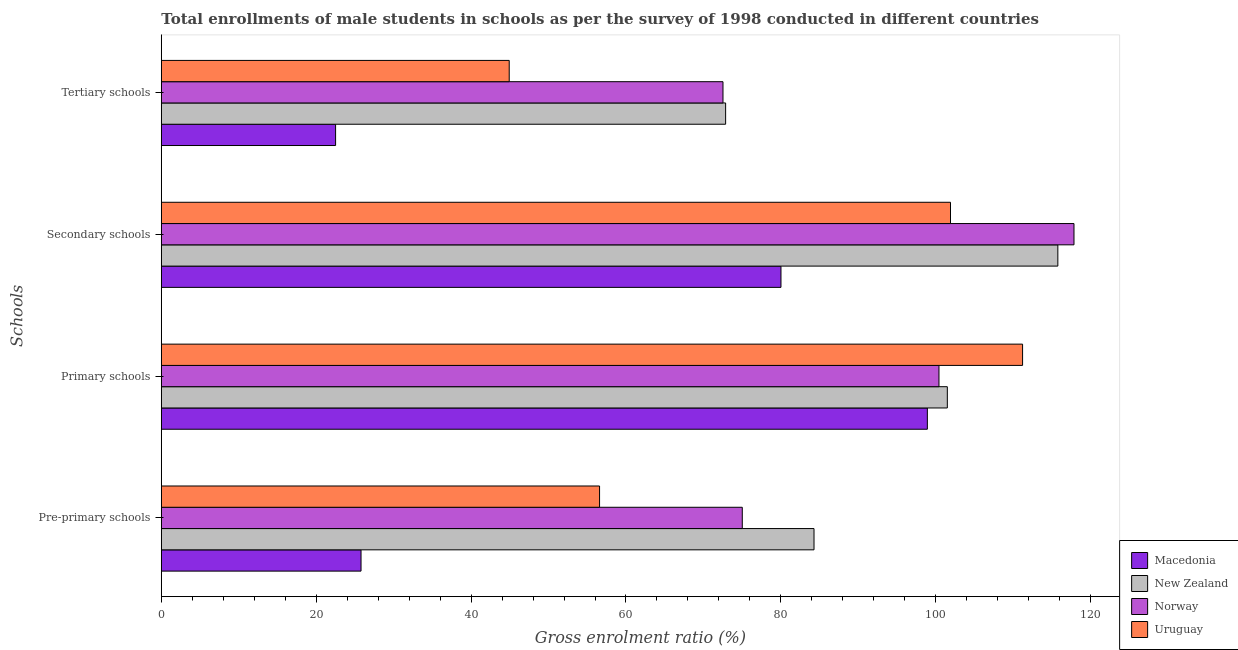How many groups of bars are there?
Make the answer very short. 4. How many bars are there on the 1st tick from the top?
Offer a terse response. 4. What is the label of the 4th group of bars from the top?
Your answer should be very brief. Pre-primary schools. What is the gross enrolment ratio(male) in pre-primary schools in Uruguay?
Your response must be concise. 56.59. Across all countries, what is the maximum gross enrolment ratio(male) in secondary schools?
Provide a succinct answer. 117.85. Across all countries, what is the minimum gross enrolment ratio(male) in primary schools?
Your answer should be compact. 98.91. In which country was the gross enrolment ratio(male) in tertiary schools maximum?
Your response must be concise. New Zealand. In which country was the gross enrolment ratio(male) in primary schools minimum?
Offer a very short reply. Macedonia. What is the total gross enrolment ratio(male) in tertiary schools in the graph?
Offer a terse response. 212.81. What is the difference between the gross enrolment ratio(male) in pre-primary schools in Macedonia and that in New Zealand?
Your response must be concise. -58.49. What is the difference between the gross enrolment ratio(male) in primary schools in Uruguay and the gross enrolment ratio(male) in secondary schools in Macedonia?
Your answer should be very brief. 31.2. What is the average gross enrolment ratio(male) in tertiary schools per country?
Give a very brief answer. 53.2. What is the difference between the gross enrolment ratio(male) in pre-primary schools and gross enrolment ratio(male) in primary schools in Norway?
Offer a very short reply. -25.4. In how many countries, is the gross enrolment ratio(male) in primary schools greater than 8 %?
Ensure brevity in your answer.  4. What is the ratio of the gross enrolment ratio(male) in pre-primary schools in Uruguay to that in New Zealand?
Provide a succinct answer. 0.67. Is the difference between the gross enrolment ratio(male) in tertiary schools in Uruguay and New Zealand greater than the difference between the gross enrolment ratio(male) in pre-primary schools in Uruguay and New Zealand?
Your response must be concise. No. What is the difference between the highest and the second highest gross enrolment ratio(male) in tertiary schools?
Your answer should be compact. 0.34. What is the difference between the highest and the lowest gross enrolment ratio(male) in tertiary schools?
Offer a very short reply. 50.36. In how many countries, is the gross enrolment ratio(male) in primary schools greater than the average gross enrolment ratio(male) in primary schools taken over all countries?
Your response must be concise. 1. Is the sum of the gross enrolment ratio(male) in secondary schools in New Zealand and Uruguay greater than the maximum gross enrolment ratio(male) in primary schools across all countries?
Give a very brief answer. Yes. What does the 2nd bar from the top in Tertiary schools represents?
Offer a very short reply. Norway. What does the 4th bar from the bottom in Secondary schools represents?
Your response must be concise. Uruguay. Is it the case that in every country, the sum of the gross enrolment ratio(male) in pre-primary schools and gross enrolment ratio(male) in primary schools is greater than the gross enrolment ratio(male) in secondary schools?
Ensure brevity in your answer.  Yes. How many bars are there?
Offer a very short reply. 16. Are all the bars in the graph horizontal?
Make the answer very short. Yes. How many countries are there in the graph?
Your answer should be compact. 4. Does the graph contain any zero values?
Give a very brief answer. No. How many legend labels are there?
Provide a succinct answer. 4. What is the title of the graph?
Make the answer very short. Total enrollments of male students in schools as per the survey of 1998 conducted in different countries. What is the label or title of the Y-axis?
Provide a succinct answer. Schools. What is the Gross enrolment ratio (%) of Macedonia in Pre-primary schools?
Ensure brevity in your answer.  25.79. What is the Gross enrolment ratio (%) of New Zealand in Pre-primary schools?
Your answer should be compact. 84.28. What is the Gross enrolment ratio (%) of Norway in Pre-primary schools?
Your response must be concise. 75.02. What is the Gross enrolment ratio (%) of Uruguay in Pre-primary schools?
Keep it short and to the point. 56.59. What is the Gross enrolment ratio (%) in Macedonia in Primary schools?
Your response must be concise. 98.91. What is the Gross enrolment ratio (%) of New Zealand in Primary schools?
Offer a terse response. 101.49. What is the Gross enrolment ratio (%) in Norway in Primary schools?
Keep it short and to the point. 100.41. What is the Gross enrolment ratio (%) of Uruguay in Primary schools?
Keep it short and to the point. 111.21. What is the Gross enrolment ratio (%) of Macedonia in Secondary schools?
Offer a very short reply. 80.01. What is the Gross enrolment ratio (%) in New Zealand in Secondary schools?
Give a very brief answer. 115.76. What is the Gross enrolment ratio (%) of Norway in Secondary schools?
Offer a very short reply. 117.85. What is the Gross enrolment ratio (%) of Uruguay in Secondary schools?
Ensure brevity in your answer.  101.9. What is the Gross enrolment ratio (%) in Macedonia in Tertiary schools?
Ensure brevity in your answer.  22.5. What is the Gross enrolment ratio (%) in New Zealand in Tertiary schools?
Your answer should be compact. 72.86. What is the Gross enrolment ratio (%) in Norway in Tertiary schools?
Make the answer very short. 72.52. What is the Gross enrolment ratio (%) of Uruguay in Tertiary schools?
Your response must be concise. 44.92. Across all Schools, what is the maximum Gross enrolment ratio (%) in Macedonia?
Your response must be concise. 98.91. Across all Schools, what is the maximum Gross enrolment ratio (%) of New Zealand?
Ensure brevity in your answer.  115.76. Across all Schools, what is the maximum Gross enrolment ratio (%) of Norway?
Give a very brief answer. 117.85. Across all Schools, what is the maximum Gross enrolment ratio (%) of Uruguay?
Your answer should be very brief. 111.21. Across all Schools, what is the minimum Gross enrolment ratio (%) in Macedonia?
Make the answer very short. 22.5. Across all Schools, what is the minimum Gross enrolment ratio (%) in New Zealand?
Your answer should be very brief. 72.86. Across all Schools, what is the minimum Gross enrolment ratio (%) of Norway?
Offer a very short reply. 72.52. Across all Schools, what is the minimum Gross enrolment ratio (%) in Uruguay?
Ensure brevity in your answer.  44.92. What is the total Gross enrolment ratio (%) in Macedonia in the graph?
Offer a very short reply. 227.22. What is the total Gross enrolment ratio (%) of New Zealand in the graph?
Your answer should be very brief. 374.4. What is the total Gross enrolment ratio (%) in Norway in the graph?
Ensure brevity in your answer.  365.8. What is the total Gross enrolment ratio (%) of Uruguay in the graph?
Give a very brief answer. 314.62. What is the difference between the Gross enrolment ratio (%) in Macedonia in Pre-primary schools and that in Primary schools?
Provide a succinct answer. -73.13. What is the difference between the Gross enrolment ratio (%) of New Zealand in Pre-primary schools and that in Primary schools?
Make the answer very short. -17.21. What is the difference between the Gross enrolment ratio (%) of Norway in Pre-primary schools and that in Primary schools?
Your answer should be very brief. -25.4. What is the difference between the Gross enrolment ratio (%) in Uruguay in Pre-primary schools and that in Primary schools?
Your answer should be very brief. -54.62. What is the difference between the Gross enrolment ratio (%) of Macedonia in Pre-primary schools and that in Secondary schools?
Provide a succinct answer. -54.23. What is the difference between the Gross enrolment ratio (%) in New Zealand in Pre-primary schools and that in Secondary schools?
Make the answer very short. -31.49. What is the difference between the Gross enrolment ratio (%) in Norway in Pre-primary schools and that in Secondary schools?
Provide a short and direct response. -42.83. What is the difference between the Gross enrolment ratio (%) in Uruguay in Pre-primary schools and that in Secondary schools?
Your answer should be compact. -45.32. What is the difference between the Gross enrolment ratio (%) in Macedonia in Pre-primary schools and that in Tertiary schools?
Offer a terse response. 3.28. What is the difference between the Gross enrolment ratio (%) of New Zealand in Pre-primary schools and that in Tertiary schools?
Ensure brevity in your answer.  11.41. What is the difference between the Gross enrolment ratio (%) of Norway in Pre-primary schools and that in Tertiary schools?
Ensure brevity in your answer.  2.49. What is the difference between the Gross enrolment ratio (%) of Uruguay in Pre-primary schools and that in Tertiary schools?
Offer a very short reply. 11.67. What is the difference between the Gross enrolment ratio (%) of Macedonia in Primary schools and that in Secondary schools?
Ensure brevity in your answer.  18.9. What is the difference between the Gross enrolment ratio (%) in New Zealand in Primary schools and that in Secondary schools?
Your answer should be compact. -14.27. What is the difference between the Gross enrolment ratio (%) in Norway in Primary schools and that in Secondary schools?
Keep it short and to the point. -17.43. What is the difference between the Gross enrolment ratio (%) of Uruguay in Primary schools and that in Secondary schools?
Your answer should be very brief. 9.31. What is the difference between the Gross enrolment ratio (%) of Macedonia in Primary schools and that in Tertiary schools?
Ensure brevity in your answer.  76.41. What is the difference between the Gross enrolment ratio (%) of New Zealand in Primary schools and that in Tertiary schools?
Offer a very short reply. 28.63. What is the difference between the Gross enrolment ratio (%) in Norway in Primary schools and that in Tertiary schools?
Your answer should be very brief. 27.89. What is the difference between the Gross enrolment ratio (%) of Uruguay in Primary schools and that in Tertiary schools?
Provide a succinct answer. 66.29. What is the difference between the Gross enrolment ratio (%) in Macedonia in Secondary schools and that in Tertiary schools?
Ensure brevity in your answer.  57.51. What is the difference between the Gross enrolment ratio (%) in New Zealand in Secondary schools and that in Tertiary schools?
Provide a short and direct response. 42.9. What is the difference between the Gross enrolment ratio (%) of Norway in Secondary schools and that in Tertiary schools?
Ensure brevity in your answer.  45.32. What is the difference between the Gross enrolment ratio (%) in Uruguay in Secondary schools and that in Tertiary schools?
Your answer should be compact. 56.98. What is the difference between the Gross enrolment ratio (%) of Macedonia in Pre-primary schools and the Gross enrolment ratio (%) of New Zealand in Primary schools?
Offer a terse response. -75.71. What is the difference between the Gross enrolment ratio (%) in Macedonia in Pre-primary schools and the Gross enrolment ratio (%) in Norway in Primary schools?
Your answer should be very brief. -74.63. What is the difference between the Gross enrolment ratio (%) in Macedonia in Pre-primary schools and the Gross enrolment ratio (%) in Uruguay in Primary schools?
Keep it short and to the point. -85.42. What is the difference between the Gross enrolment ratio (%) in New Zealand in Pre-primary schools and the Gross enrolment ratio (%) in Norway in Primary schools?
Offer a very short reply. -16.13. What is the difference between the Gross enrolment ratio (%) in New Zealand in Pre-primary schools and the Gross enrolment ratio (%) in Uruguay in Primary schools?
Give a very brief answer. -26.93. What is the difference between the Gross enrolment ratio (%) in Norway in Pre-primary schools and the Gross enrolment ratio (%) in Uruguay in Primary schools?
Your answer should be very brief. -36.19. What is the difference between the Gross enrolment ratio (%) of Macedonia in Pre-primary schools and the Gross enrolment ratio (%) of New Zealand in Secondary schools?
Ensure brevity in your answer.  -89.98. What is the difference between the Gross enrolment ratio (%) in Macedonia in Pre-primary schools and the Gross enrolment ratio (%) in Norway in Secondary schools?
Keep it short and to the point. -92.06. What is the difference between the Gross enrolment ratio (%) of Macedonia in Pre-primary schools and the Gross enrolment ratio (%) of Uruguay in Secondary schools?
Provide a succinct answer. -76.12. What is the difference between the Gross enrolment ratio (%) of New Zealand in Pre-primary schools and the Gross enrolment ratio (%) of Norway in Secondary schools?
Offer a very short reply. -33.57. What is the difference between the Gross enrolment ratio (%) in New Zealand in Pre-primary schools and the Gross enrolment ratio (%) in Uruguay in Secondary schools?
Offer a very short reply. -17.63. What is the difference between the Gross enrolment ratio (%) in Norway in Pre-primary schools and the Gross enrolment ratio (%) in Uruguay in Secondary schools?
Offer a terse response. -26.89. What is the difference between the Gross enrolment ratio (%) of Macedonia in Pre-primary schools and the Gross enrolment ratio (%) of New Zealand in Tertiary schools?
Provide a short and direct response. -47.08. What is the difference between the Gross enrolment ratio (%) of Macedonia in Pre-primary schools and the Gross enrolment ratio (%) of Norway in Tertiary schools?
Offer a very short reply. -46.74. What is the difference between the Gross enrolment ratio (%) in Macedonia in Pre-primary schools and the Gross enrolment ratio (%) in Uruguay in Tertiary schools?
Give a very brief answer. -19.14. What is the difference between the Gross enrolment ratio (%) of New Zealand in Pre-primary schools and the Gross enrolment ratio (%) of Norway in Tertiary schools?
Provide a succinct answer. 11.75. What is the difference between the Gross enrolment ratio (%) of New Zealand in Pre-primary schools and the Gross enrolment ratio (%) of Uruguay in Tertiary schools?
Keep it short and to the point. 39.36. What is the difference between the Gross enrolment ratio (%) of Norway in Pre-primary schools and the Gross enrolment ratio (%) of Uruguay in Tertiary schools?
Make the answer very short. 30.1. What is the difference between the Gross enrolment ratio (%) in Macedonia in Primary schools and the Gross enrolment ratio (%) in New Zealand in Secondary schools?
Your response must be concise. -16.85. What is the difference between the Gross enrolment ratio (%) of Macedonia in Primary schools and the Gross enrolment ratio (%) of Norway in Secondary schools?
Provide a succinct answer. -18.93. What is the difference between the Gross enrolment ratio (%) of Macedonia in Primary schools and the Gross enrolment ratio (%) of Uruguay in Secondary schools?
Provide a short and direct response. -2.99. What is the difference between the Gross enrolment ratio (%) of New Zealand in Primary schools and the Gross enrolment ratio (%) of Norway in Secondary schools?
Provide a succinct answer. -16.35. What is the difference between the Gross enrolment ratio (%) of New Zealand in Primary schools and the Gross enrolment ratio (%) of Uruguay in Secondary schools?
Offer a very short reply. -0.41. What is the difference between the Gross enrolment ratio (%) in Norway in Primary schools and the Gross enrolment ratio (%) in Uruguay in Secondary schools?
Ensure brevity in your answer.  -1.49. What is the difference between the Gross enrolment ratio (%) of Macedonia in Primary schools and the Gross enrolment ratio (%) of New Zealand in Tertiary schools?
Make the answer very short. 26.05. What is the difference between the Gross enrolment ratio (%) of Macedonia in Primary schools and the Gross enrolment ratio (%) of Norway in Tertiary schools?
Your response must be concise. 26.39. What is the difference between the Gross enrolment ratio (%) in Macedonia in Primary schools and the Gross enrolment ratio (%) in Uruguay in Tertiary schools?
Offer a terse response. 53.99. What is the difference between the Gross enrolment ratio (%) of New Zealand in Primary schools and the Gross enrolment ratio (%) of Norway in Tertiary schools?
Offer a very short reply. 28.97. What is the difference between the Gross enrolment ratio (%) of New Zealand in Primary schools and the Gross enrolment ratio (%) of Uruguay in Tertiary schools?
Your answer should be very brief. 56.57. What is the difference between the Gross enrolment ratio (%) in Norway in Primary schools and the Gross enrolment ratio (%) in Uruguay in Tertiary schools?
Your answer should be very brief. 55.49. What is the difference between the Gross enrolment ratio (%) in Macedonia in Secondary schools and the Gross enrolment ratio (%) in New Zealand in Tertiary schools?
Ensure brevity in your answer.  7.15. What is the difference between the Gross enrolment ratio (%) of Macedonia in Secondary schools and the Gross enrolment ratio (%) of Norway in Tertiary schools?
Ensure brevity in your answer.  7.49. What is the difference between the Gross enrolment ratio (%) of Macedonia in Secondary schools and the Gross enrolment ratio (%) of Uruguay in Tertiary schools?
Make the answer very short. 35.09. What is the difference between the Gross enrolment ratio (%) of New Zealand in Secondary schools and the Gross enrolment ratio (%) of Norway in Tertiary schools?
Your response must be concise. 43.24. What is the difference between the Gross enrolment ratio (%) of New Zealand in Secondary schools and the Gross enrolment ratio (%) of Uruguay in Tertiary schools?
Make the answer very short. 70.84. What is the difference between the Gross enrolment ratio (%) of Norway in Secondary schools and the Gross enrolment ratio (%) of Uruguay in Tertiary schools?
Provide a succinct answer. 72.92. What is the average Gross enrolment ratio (%) in Macedonia per Schools?
Ensure brevity in your answer.  56.8. What is the average Gross enrolment ratio (%) in New Zealand per Schools?
Provide a short and direct response. 93.6. What is the average Gross enrolment ratio (%) of Norway per Schools?
Offer a very short reply. 91.45. What is the average Gross enrolment ratio (%) in Uruguay per Schools?
Offer a terse response. 78.66. What is the difference between the Gross enrolment ratio (%) in Macedonia and Gross enrolment ratio (%) in New Zealand in Pre-primary schools?
Provide a short and direct response. -58.49. What is the difference between the Gross enrolment ratio (%) in Macedonia and Gross enrolment ratio (%) in Norway in Pre-primary schools?
Ensure brevity in your answer.  -49.23. What is the difference between the Gross enrolment ratio (%) in Macedonia and Gross enrolment ratio (%) in Uruguay in Pre-primary schools?
Keep it short and to the point. -30.8. What is the difference between the Gross enrolment ratio (%) of New Zealand and Gross enrolment ratio (%) of Norway in Pre-primary schools?
Provide a short and direct response. 9.26. What is the difference between the Gross enrolment ratio (%) in New Zealand and Gross enrolment ratio (%) in Uruguay in Pre-primary schools?
Offer a very short reply. 27.69. What is the difference between the Gross enrolment ratio (%) of Norway and Gross enrolment ratio (%) of Uruguay in Pre-primary schools?
Your answer should be compact. 18.43. What is the difference between the Gross enrolment ratio (%) of Macedonia and Gross enrolment ratio (%) of New Zealand in Primary schools?
Your answer should be compact. -2.58. What is the difference between the Gross enrolment ratio (%) in Macedonia and Gross enrolment ratio (%) in Norway in Primary schools?
Give a very brief answer. -1.5. What is the difference between the Gross enrolment ratio (%) of Macedonia and Gross enrolment ratio (%) of Uruguay in Primary schools?
Your response must be concise. -12.3. What is the difference between the Gross enrolment ratio (%) of New Zealand and Gross enrolment ratio (%) of Norway in Primary schools?
Provide a short and direct response. 1.08. What is the difference between the Gross enrolment ratio (%) of New Zealand and Gross enrolment ratio (%) of Uruguay in Primary schools?
Your answer should be compact. -9.72. What is the difference between the Gross enrolment ratio (%) in Norway and Gross enrolment ratio (%) in Uruguay in Primary schools?
Offer a terse response. -10.8. What is the difference between the Gross enrolment ratio (%) of Macedonia and Gross enrolment ratio (%) of New Zealand in Secondary schools?
Make the answer very short. -35.75. What is the difference between the Gross enrolment ratio (%) in Macedonia and Gross enrolment ratio (%) in Norway in Secondary schools?
Your answer should be compact. -37.83. What is the difference between the Gross enrolment ratio (%) of Macedonia and Gross enrolment ratio (%) of Uruguay in Secondary schools?
Your answer should be very brief. -21.89. What is the difference between the Gross enrolment ratio (%) in New Zealand and Gross enrolment ratio (%) in Norway in Secondary schools?
Your response must be concise. -2.08. What is the difference between the Gross enrolment ratio (%) of New Zealand and Gross enrolment ratio (%) of Uruguay in Secondary schools?
Your answer should be compact. 13.86. What is the difference between the Gross enrolment ratio (%) of Norway and Gross enrolment ratio (%) of Uruguay in Secondary schools?
Provide a succinct answer. 15.94. What is the difference between the Gross enrolment ratio (%) in Macedonia and Gross enrolment ratio (%) in New Zealand in Tertiary schools?
Your answer should be very brief. -50.36. What is the difference between the Gross enrolment ratio (%) in Macedonia and Gross enrolment ratio (%) in Norway in Tertiary schools?
Offer a terse response. -50.02. What is the difference between the Gross enrolment ratio (%) in Macedonia and Gross enrolment ratio (%) in Uruguay in Tertiary schools?
Keep it short and to the point. -22.42. What is the difference between the Gross enrolment ratio (%) of New Zealand and Gross enrolment ratio (%) of Norway in Tertiary schools?
Your answer should be very brief. 0.34. What is the difference between the Gross enrolment ratio (%) in New Zealand and Gross enrolment ratio (%) in Uruguay in Tertiary schools?
Offer a terse response. 27.94. What is the difference between the Gross enrolment ratio (%) of Norway and Gross enrolment ratio (%) of Uruguay in Tertiary schools?
Offer a terse response. 27.6. What is the ratio of the Gross enrolment ratio (%) in Macedonia in Pre-primary schools to that in Primary schools?
Offer a very short reply. 0.26. What is the ratio of the Gross enrolment ratio (%) of New Zealand in Pre-primary schools to that in Primary schools?
Keep it short and to the point. 0.83. What is the ratio of the Gross enrolment ratio (%) of Norway in Pre-primary schools to that in Primary schools?
Provide a succinct answer. 0.75. What is the ratio of the Gross enrolment ratio (%) in Uruguay in Pre-primary schools to that in Primary schools?
Provide a short and direct response. 0.51. What is the ratio of the Gross enrolment ratio (%) of Macedonia in Pre-primary schools to that in Secondary schools?
Your answer should be compact. 0.32. What is the ratio of the Gross enrolment ratio (%) of New Zealand in Pre-primary schools to that in Secondary schools?
Offer a very short reply. 0.73. What is the ratio of the Gross enrolment ratio (%) in Norway in Pre-primary schools to that in Secondary schools?
Make the answer very short. 0.64. What is the ratio of the Gross enrolment ratio (%) of Uruguay in Pre-primary schools to that in Secondary schools?
Offer a terse response. 0.56. What is the ratio of the Gross enrolment ratio (%) in Macedonia in Pre-primary schools to that in Tertiary schools?
Offer a terse response. 1.15. What is the ratio of the Gross enrolment ratio (%) in New Zealand in Pre-primary schools to that in Tertiary schools?
Ensure brevity in your answer.  1.16. What is the ratio of the Gross enrolment ratio (%) in Norway in Pre-primary schools to that in Tertiary schools?
Provide a short and direct response. 1.03. What is the ratio of the Gross enrolment ratio (%) in Uruguay in Pre-primary schools to that in Tertiary schools?
Offer a terse response. 1.26. What is the ratio of the Gross enrolment ratio (%) in Macedonia in Primary schools to that in Secondary schools?
Give a very brief answer. 1.24. What is the ratio of the Gross enrolment ratio (%) of New Zealand in Primary schools to that in Secondary schools?
Offer a terse response. 0.88. What is the ratio of the Gross enrolment ratio (%) in Norway in Primary schools to that in Secondary schools?
Offer a terse response. 0.85. What is the ratio of the Gross enrolment ratio (%) of Uruguay in Primary schools to that in Secondary schools?
Your answer should be compact. 1.09. What is the ratio of the Gross enrolment ratio (%) of Macedonia in Primary schools to that in Tertiary schools?
Make the answer very short. 4.4. What is the ratio of the Gross enrolment ratio (%) of New Zealand in Primary schools to that in Tertiary schools?
Make the answer very short. 1.39. What is the ratio of the Gross enrolment ratio (%) of Norway in Primary schools to that in Tertiary schools?
Give a very brief answer. 1.38. What is the ratio of the Gross enrolment ratio (%) in Uruguay in Primary schools to that in Tertiary schools?
Keep it short and to the point. 2.48. What is the ratio of the Gross enrolment ratio (%) of Macedonia in Secondary schools to that in Tertiary schools?
Keep it short and to the point. 3.56. What is the ratio of the Gross enrolment ratio (%) of New Zealand in Secondary schools to that in Tertiary schools?
Provide a succinct answer. 1.59. What is the ratio of the Gross enrolment ratio (%) of Norway in Secondary schools to that in Tertiary schools?
Your answer should be very brief. 1.62. What is the ratio of the Gross enrolment ratio (%) of Uruguay in Secondary schools to that in Tertiary schools?
Your answer should be very brief. 2.27. What is the difference between the highest and the second highest Gross enrolment ratio (%) in Macedonia?
Your answer should be compact. 18.9. What is the difference between the highest and the second highest Gross enrolment ratio (%) in New Zealand?
Provide a succinct answer. 14.27. What is the difference between the highest and the second highest Gross enrolment ratio (%) in Norway?
Keep it short and to the point. 17.43. What is the difference between the highest and the second highest Gross enrolment ratio (%) of Uruguay?
Your answer should be very brief. 9.31. What is the difference between the highest and the lowest Gross enrolment ratio (%) in Macedonia?
Ensure brevity in your answer.  76.41. What is the difference between the highest and the lowest Gross enrolment ratio (%) in New Zealand?
Offer a terse response. 42.9. What is the difference between the highest and the lowest Gross enrolment ratio (%) in Norway?
Keep it short and to the point. 45.32. What is the difference between the highest and the lowest Gross enrolment ratio (%) of Uruguay?
Provide a short and direct response. 66.29. 